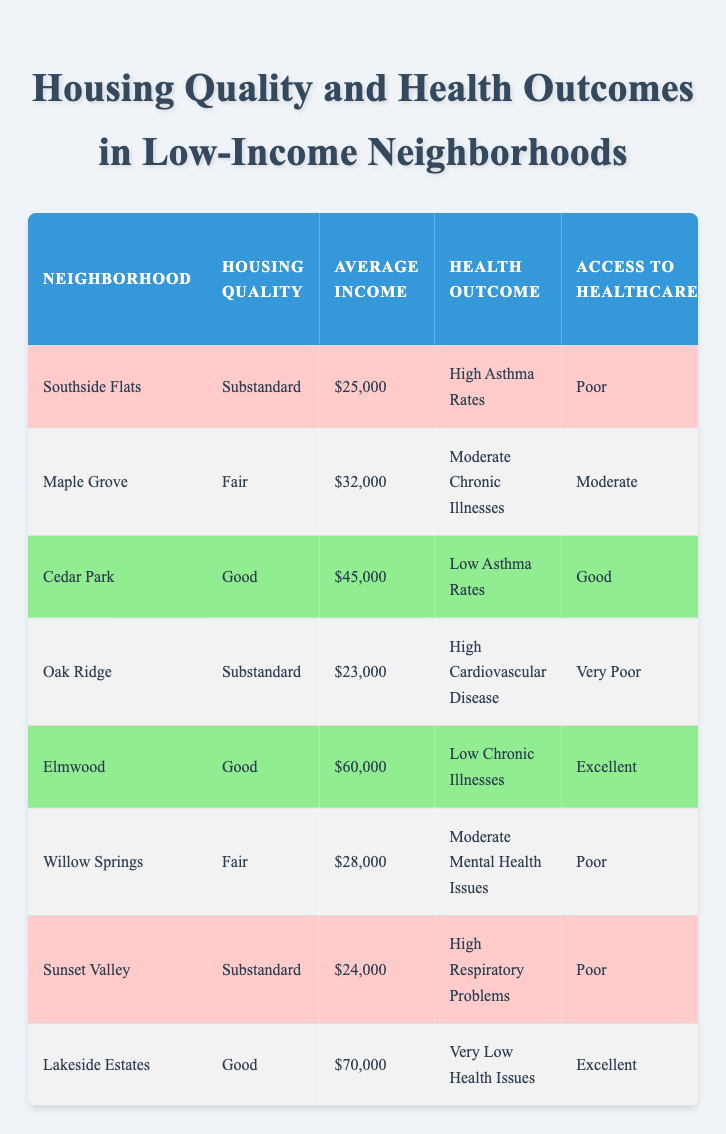What is the housing quality of Lakeside Estates? Lakeside Estates is listed under the "Housing Quality" column, which shows it has a "Good" rating.
Answer: Good Which neighborhood has the highest reported mental health issues? To find this, we look at the "Reported Mental Health Issues" column. Oak Ridge has "Very High," which is the highest listed value.
Answer: Oak Ridge What is the average income of neighborhoods with substandard housing quality? The substandard neighborhoods are Southside Flats ($25,000), Oak Ridge ($23,000), and Sunset Valley ($24,000). Their total income is $25,000 + $23,000 + $24,000 = $72,000, divided by 3 neighborhoods gives an average of $72,000/3 = $24,000.
Answer: $24,000 Do all neighborhoods with good housing quality have low health issues? Cedar Park and Elmwood have good housing quality, with health outcomes listed as "Low Asthma Rates" and "Low Chronic Illnesses," while Lakeside Estates has "Very Low Health Issues." This indicates they all have low health issues corresponding to good housing.
Answer: Yes Which neighborhood has the lowest access to healthcare and what is its housing quality? Reviewing the "Access to Healthcare" column, Oak Ridge has "Very Poor," and its housing quality is listed as "Substandard."
Answer: Oak Ridge, Substandard What is the combined average income of neighborhoods with fair housing quality? The neighborhoods with fair housing quality are Maple Grove ($32,000) and Willow Springs ($28,000). Their total income is $32,000 + $28,000 = $60,000, therefore, the average is $60,000/2 = $30,000.
Answer: $30,000 Is it true that all neighborhoods with good housing quality have excellent access to healthcare? There are three neighborhoods with good housing quality: Cedar Park (Good access), Elmwood (Excellent access), and Lakeside Estates (Excellent access). This indicates that all neighborhoods with good housing quality also have good or excellent access to healthcare.
Answer: Yes What is the percentage of neighborhoods with substandard housing quality that report high health issues? There are three neighborhoods that fall under substandard housing: Southside Flats, Oak Ridge, and Sunset Valley. Out of these, all three report high health issues (like high asthma rates, high cardiovascular disease, and high respiratory problems), resulting in (3/3) * 100 = 100%.
Answer: 100% 